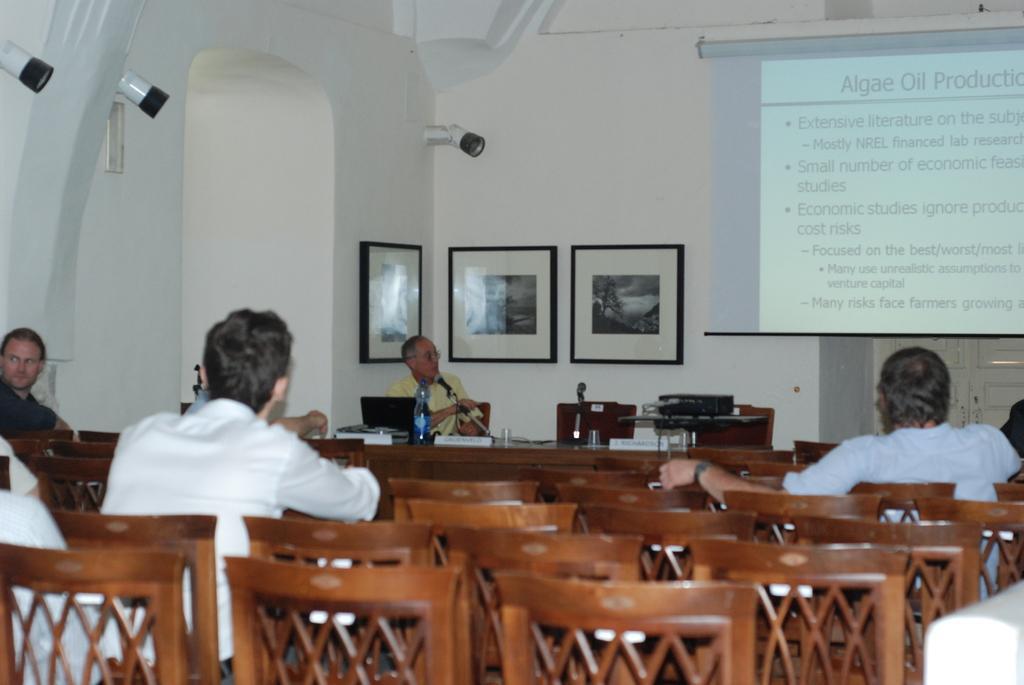How would you summarize this image in a sentence or two? There are three people sitting on the chairs. Here are empty chairs. This is a table with a water bottle,laptop name board and some other objects on it. I can see a man sitting and talking on the mike. These are the photo frames attached to the wall. This is a projector. This is the screen hanging on the wall. At background I can see the door which is closed. I think these are the lights attached to the wall. 